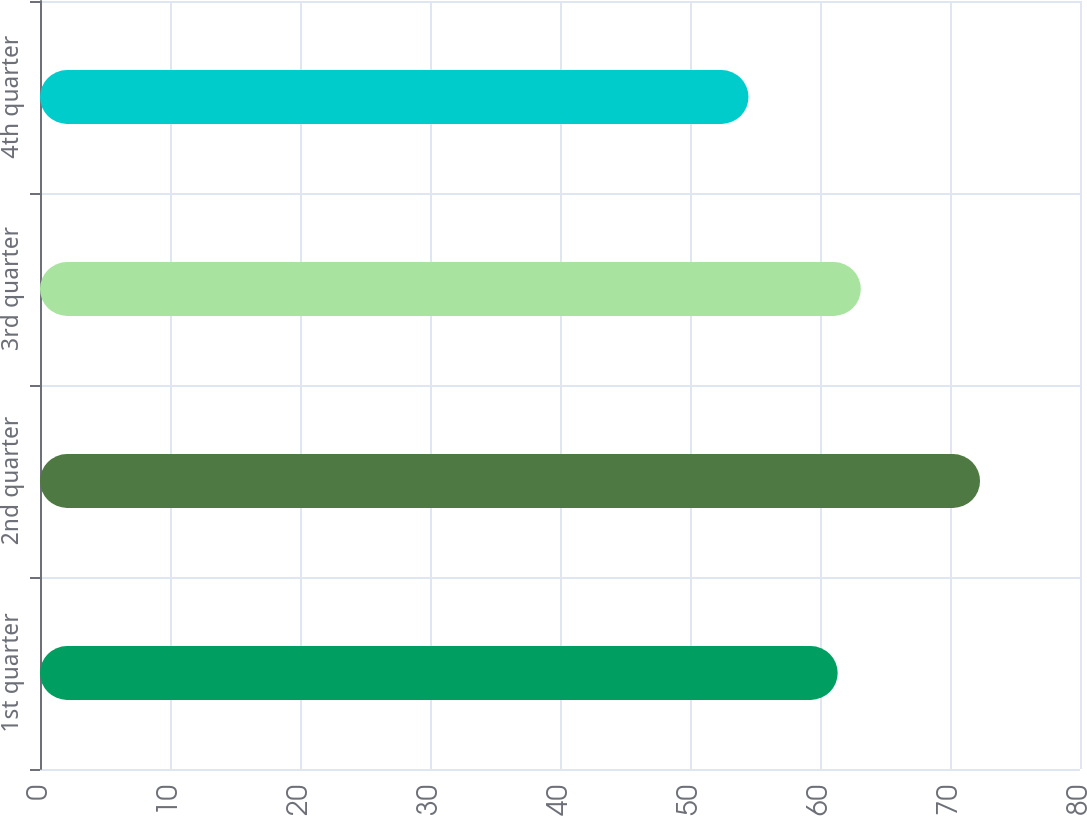Convert chart. <chart><loc_0><loc_0><loc_500><loc_500><bar_chart><fcel>1st quarter<fcel>2nd quarter<fcel>3rd quarter<fcel>4th quarter<nl><fcel>61.36<fcel>72.31<fcel>63.14<fcel>54.5<nl></chart> 